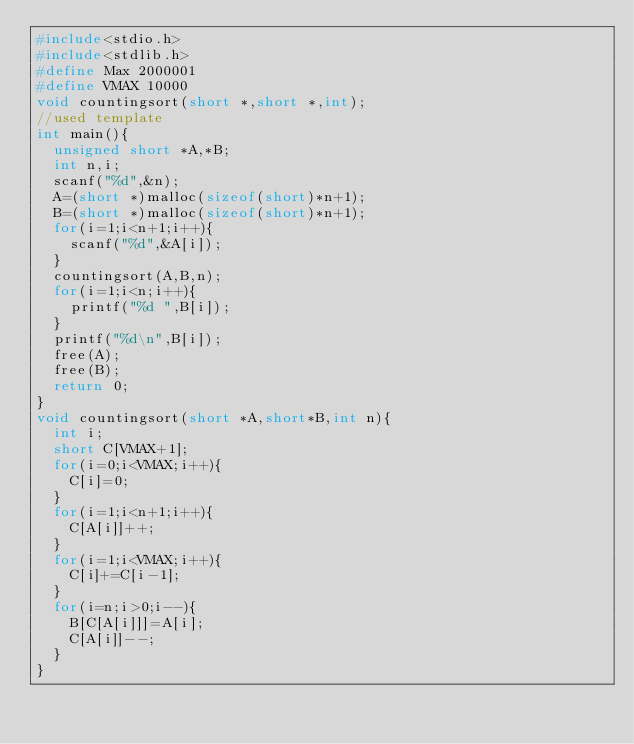<code> <loc_0><loc_0><loc_500><loc_500><_C_>#include<stdio.h>
#include<stdlib.h>
#define Max 2000001
#define VMAX 10000
void countingsort(short *,short *,int);
//used template
int main(){
  unsigned short *A,*B;
  int n,i;
  scanf("%d",&n);
  A=(short *)malloc(sizeof(short)*n+1);
  B=(short *)malloc(sizeof(short)*n+1);
  for(i=1;i<n+1;i++){
    scanf("%d",&A[i]);
  }
  countingsort(A,B,n);
  for(i=1;i<n;i++){
    printf("%d ",B[i]);
  }
  printf("%d\n",B[i]);
  free(A);
  free(B);
  return 0;
}
void countingsort(short *A,short*B,int n){
  int i;
  short C[VMAX+1];
  for(i=0;i<VMAX;i++){
    C[i]=0;
  }
  for(i=1;i<n+1;i++){
    C[A[i]]++;
  }
  for(i=1;i<VMAX;i++){
    C[i]+=C[i-1];
  }
  for(i=n;i>0;i--){
    B[C[A[i]]]=A[i];
    C[A[i]]--;
  }
}

</code> 